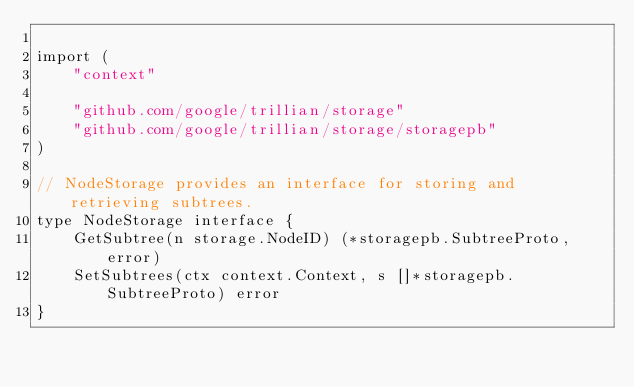Convert code to text. <code><loc_0><loc_0><loc_500><loc_500><_Go_>
import (
	"context"

	"github.com/google/trillian/storage"
	"github.com/google/trillian/storage/storagepb"
)

// NodeStorage provides an interface for storing and retrieving subtrees.
type NodeStorage interface {
	GetSubtree(n storage.NodeID) (*storagepb.SubtreeProto, error)
	SetSubtrees(ctx context.Context, s []*storagepb.SubtreeProto) error
}
</code> 